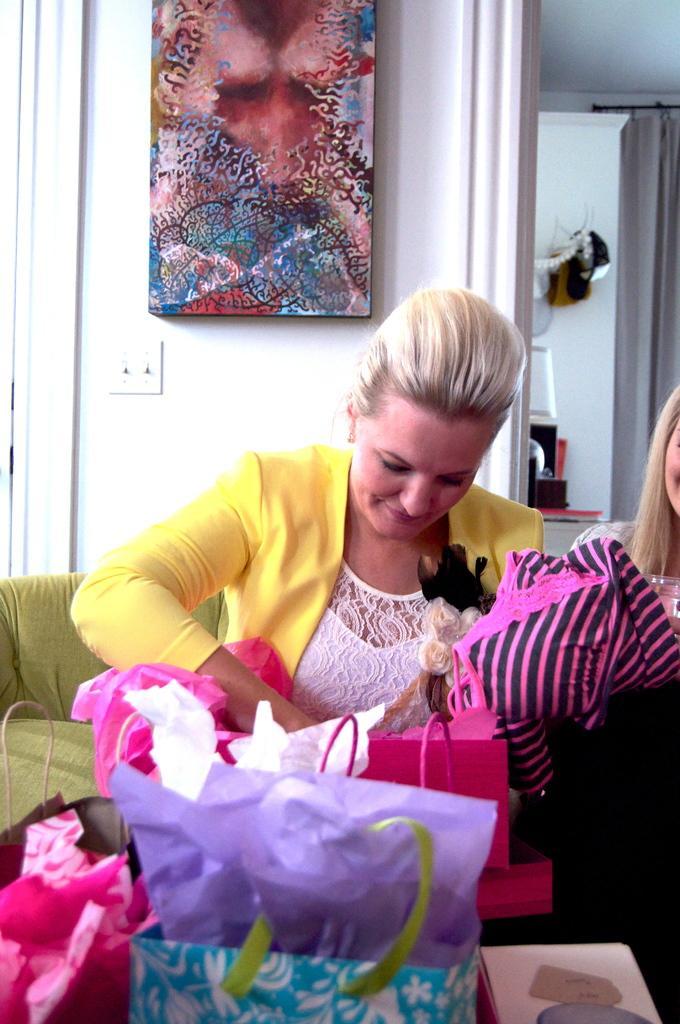Please provide a concise description of this image. In the picture we can see a woman sitting on the sofa which is green in color and she is wearing a yellow color blazer with a white dress and with her we can see some bags which are pink in color and some are blue in color and beside her we can see another woman sitting and in the background we can see a wall with painting and some switch and beside the wall we can see another room with a curtain near it. 